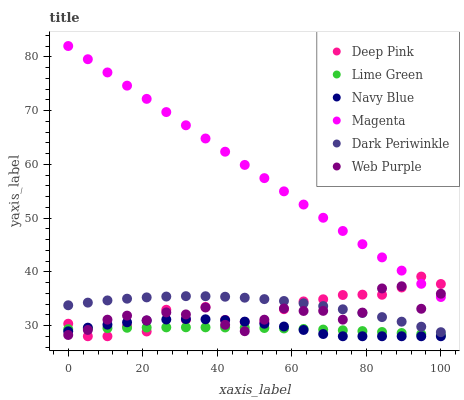Does Lime Green have the minimum area under the curve?
Answer yes or no. Yes. Does Magenta have the maximum area under the curve?
Answer yes or no. Yes. Does Navy Blue have the minimum area under the curve?
Answer yes or no. No. Does Navy Blue have the maximum area under the curve?
Answer yes or no. No. Is Magenta the smoothest?
Answer yes or no. Yes. Is Web Purple the roughest?
Answer yes or no. Yes. Is Navy Blue the smoothest?
Answer yes or no. No. Is Navy Blue the roughest?
Answer yes or no. No. Does Deep Pink have the lowest value?
Answer yes or no. Yes. Does Web Purple have the lowest value?
Answer yes or no. No. Does Magenta have the highest value?
Answer yes or no. Yes. Does Navy Blue have the highest value?
Answer yes or no. No. Is Lime Green less than Dark Periwinkle?
Answer yes or no. Yes. Is Magenta greater than Lime Green?
Answer yes or no. Yes. Does Lime Green intersect Deep Pink?
Answer yes or no. Yes. Is Lime Green less than Deep Pink?
Answer yes or no. No. Is Lime Green greater than Deep Pink?
Answer yes or no. No. Does Lime Green intersect Dark Periwinkle?
Answer yes or no. No. 